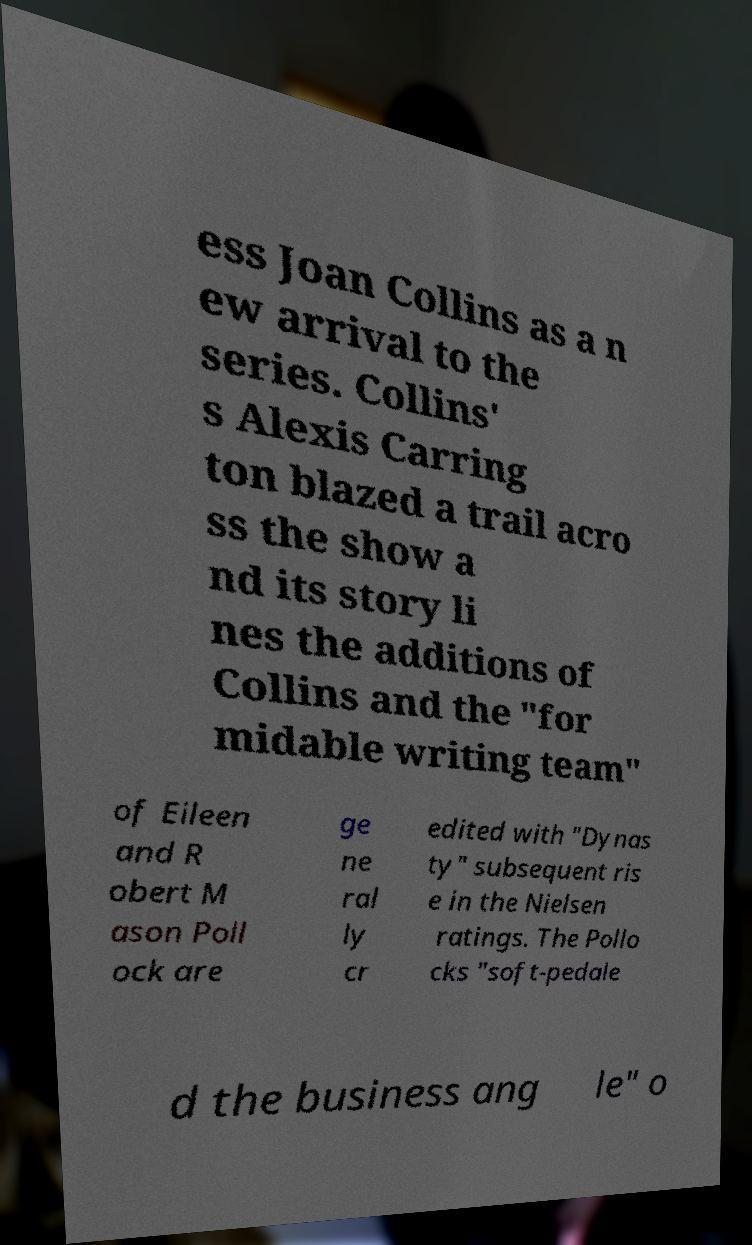For documentation purposes, I need the text within this image transcribed. Could you provide that? ess Joan Collins as a n ew arrival to the series. Collins' s Alexis Carring ton blazed a trail acro ss the show a nd its story li nes the additions of Collins and the "for midable writing team" of Eileen and R obert M ason Poll ock are ge ne ral ly cr edited with "Dynas ty" subsequent ris e in the Nielsen ratings. The Pollo cks "soft-pedale d the business ang le" o 